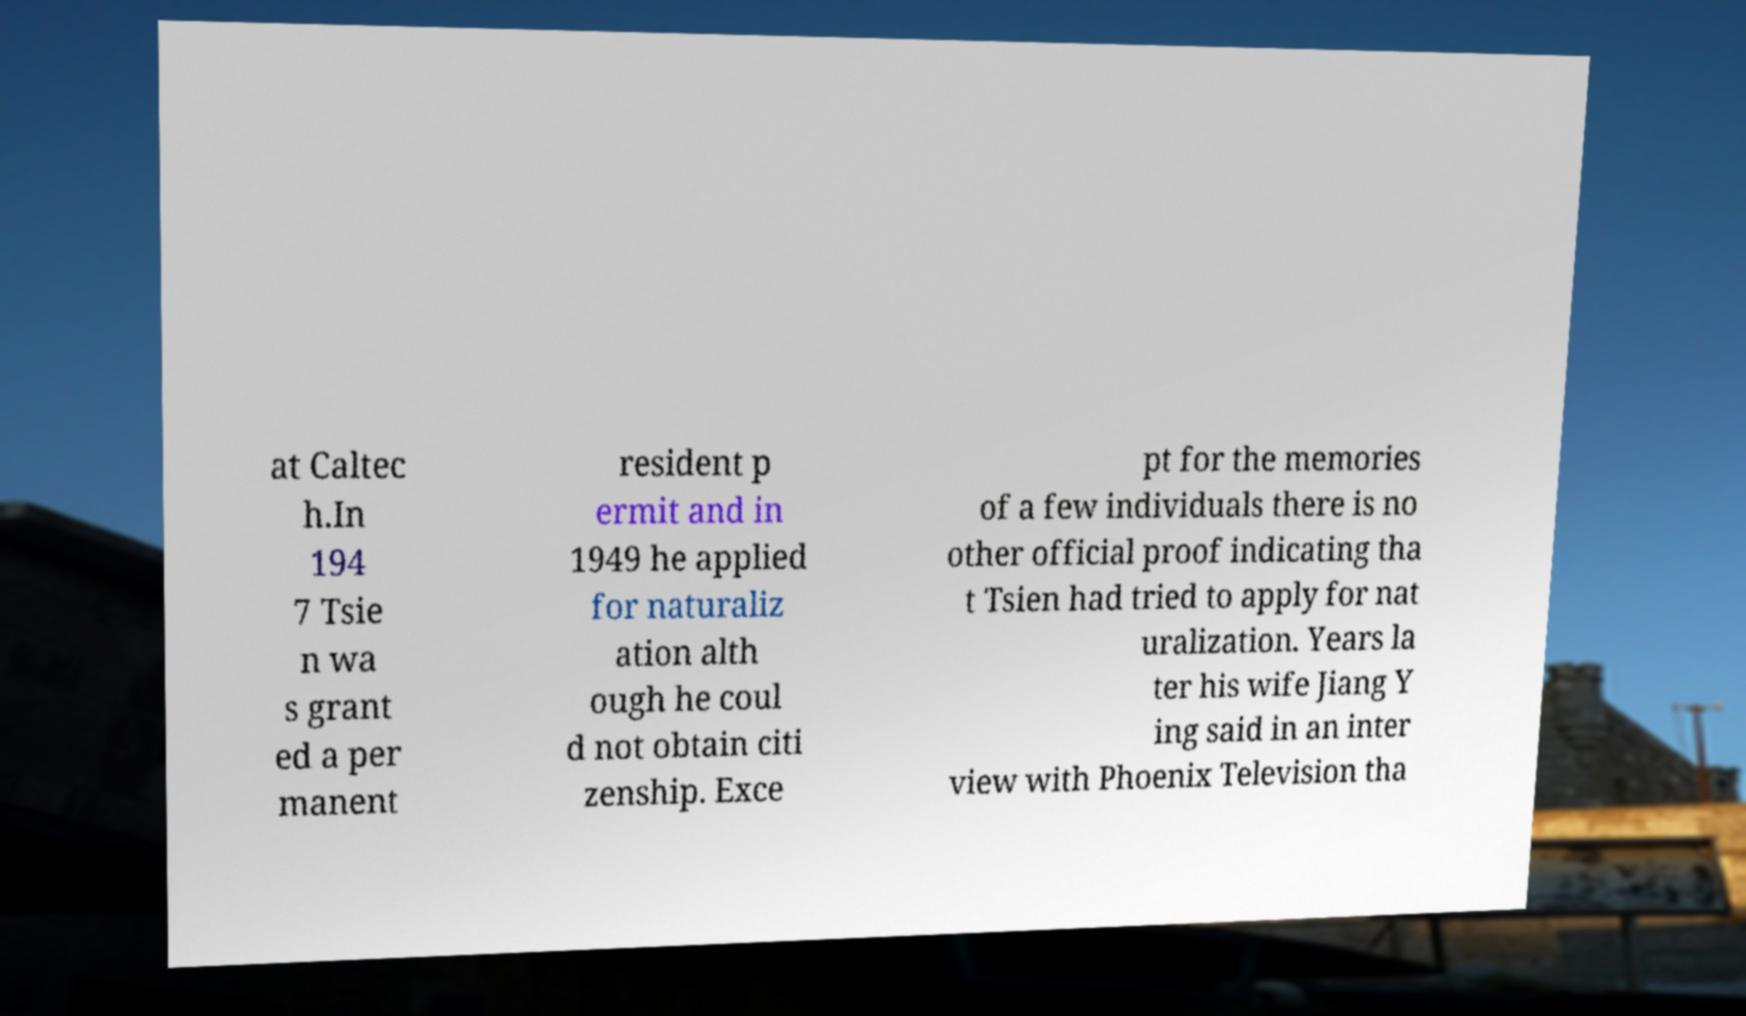For documentation purposes, I need the text within this image transcribed. Could you provide that? at Caltec h.In 194 7 Tsie n wa s grant ed a per manent resident p ermit and in 1949 he applied for naturaliz ation alth ough he coul d not obtain citi zenship. Exce pt for the memories of a few individuals there is no other official proof indicating tha t Tsien had tried to apply for nat uralization. Years la ter his wife Jiang Y ing said in an inter view with Phoenix Television tha 